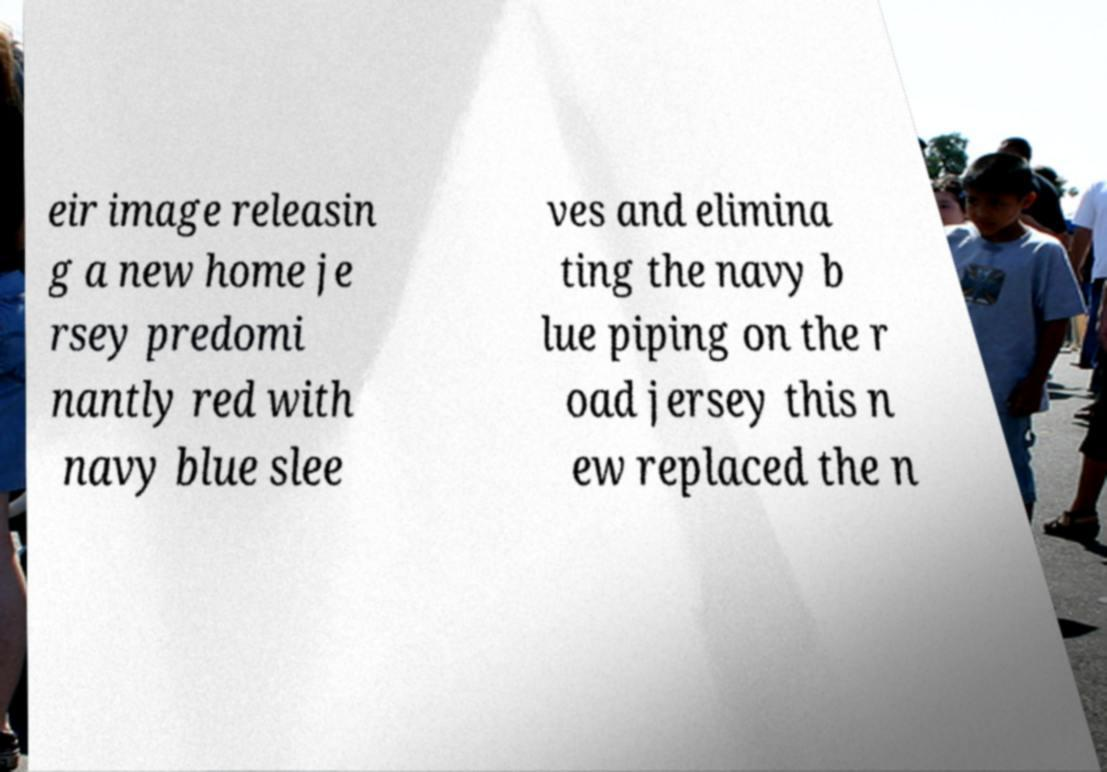What messages or text are displayed in this image? I need them in a readable, typed format. eir image releasin g a new home je rsey predomi nantly red with navy blue slee ves and elimina ting the navy b lue piping on the r oad jersey this n ew replaced the n 